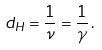<formula> <loc_0><loc_0><loc_500><loc_500>d _ { H } = \frac { 1 } { \nu } = \frac { 1 } { \gamma } \, .</formula> 